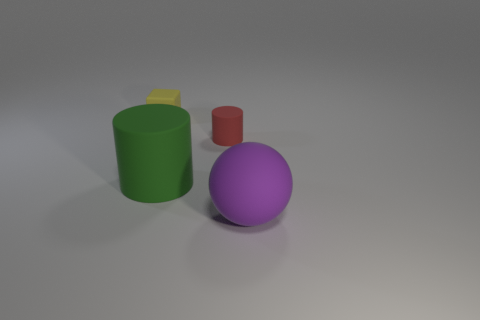Add 1 rubber cubes. How many objects exist? 5 Subtract all balls. How many objects are left? 3 Add 3 purple balls. How many purple balls are left? 4 Add 3 shiny cylinders. How many shiny cylinders exist? 3 Subtract 0 red cubes. How many objects are left? 4 Subtract all rubber things. Subtract all tiny yellow metallic things. How many objects are left? 0 